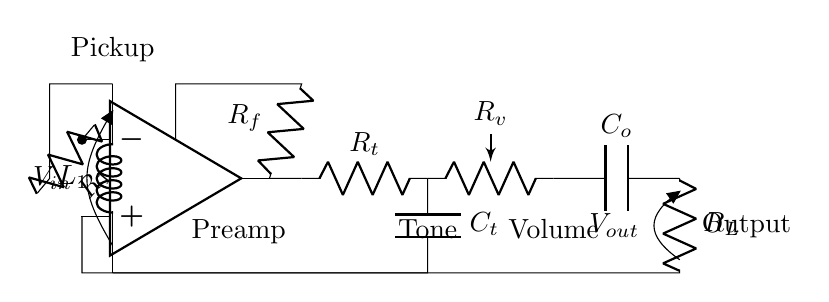What is the input voltage of the circuit? The input voltage is labeled as V_in, depicted at the top of the pickup component. This indicates the voltage is supplied from the pickup coil to the circuit.
Answer: V_in What component is used for tone control? The tone control is represented by a resistor labeled R_t and a capacitor labeled C_t, which are connected together in series. This configuration is typically used to shape the frequency response of the audio signal.
Answer: R_t and C_t How many resistors are present in the circuit? The circuit includes four resistors: R_1, R_f, R_t, and R_v. Each plays a role in the amplification and tonal adjustment of the signal.
Answer: 4 What is the function of the op-amp in this circuit? The op-amp is responsible for amplifying the input signal coming from the pickup coil. It enhances the signal strength before further processing by the tone and volume controls.
Answer: Amplify What is the output component labeled as? The output component is labeled as V_out, which indicates where the final output signal of the circuit can be accessed. It signifies the end of the signal chain after amplification and processing.
Answer: V_out How does the feedback network influence the circuit? The feedback network consisting of R_f is connected from the output of the op-amp back to its inverting input. This influences the gain of the op-amp, helping to stabilize and define the amplification level of the signal.
Answer: Gain control What role does the capacitor C_o serve in the output stage? The capacitor C_o, connected at the output stage, typically serves to decouple any AC signals from the DC output, ensuring that only the desired DC voltage is present at V_out without AC noise interference.
Answer: Decoupling 